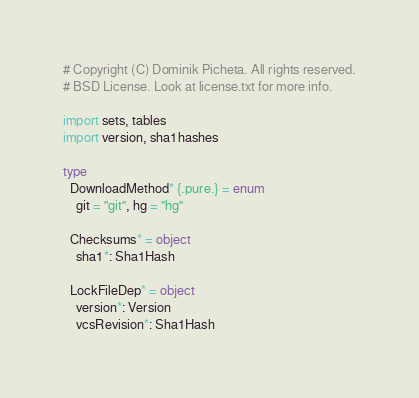Convert code to text. <code><loc_0><loc_0><loc_500><loc_500><_Nim_># Copyright (C) Dominik Picheta. All rights reserved.
# BSD License. Look at license.txt for more info.

import sets, tables
import version, sha1hashes

type
  DownloadMethod* {.pure.} = enum
    git = "git", hg = "hg"

  Checksums* = object
    sha1*: Sha1Hash

  LockFileDep* = object
    version*: Version
    vcsRevision*: Sha1Hash</code> 